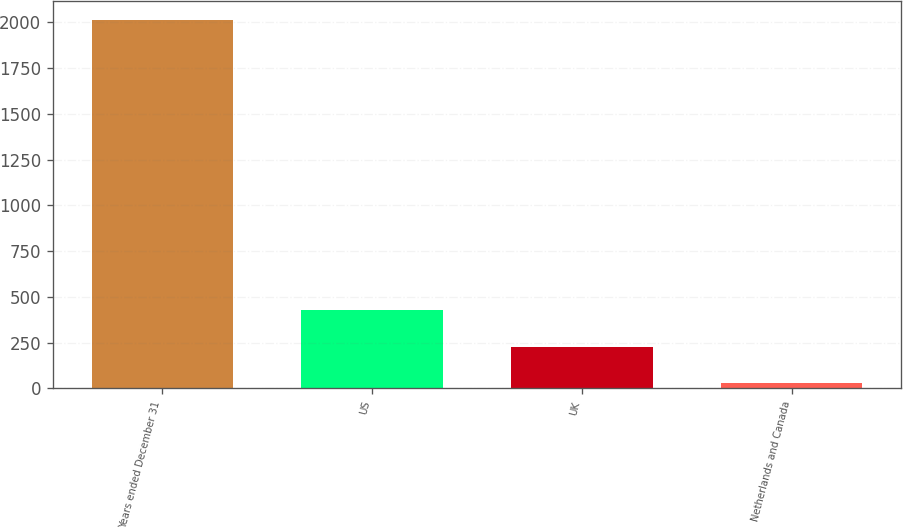Convert chart. <chart><loc_0><loc_0><loc_500><loc_500><bar_chart><fcel>Years ended December 31<fcel>US<fcel>UK<fcel>Netherlands and Canada<nl><fcel>2014<fcel>426.8<fcel>228.4<fcel>30<nl></chart> 